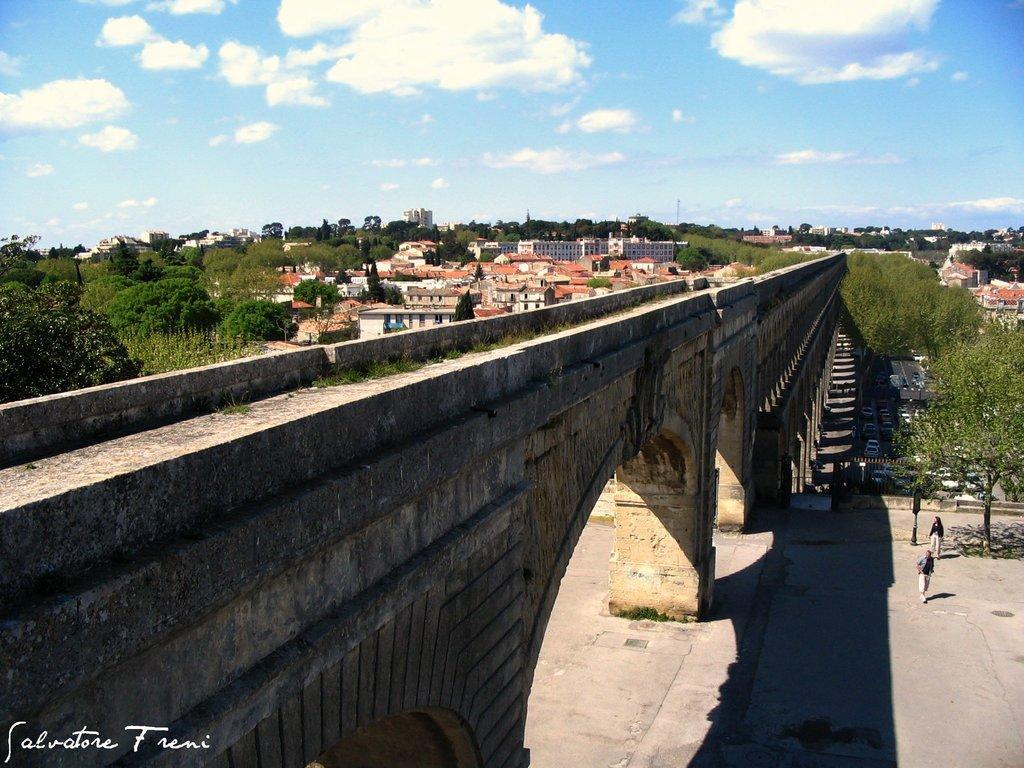Could you give a brief overview of what you see in this image? In this picture we can see few arches on the bridge. There are few people visible on the path on the right side. We can see few vehicles on the road. There are few poles and a board is seen on the pole. We can see some trees and buildings on the left and right side of the image. Sky is blue in color and cloudy. 